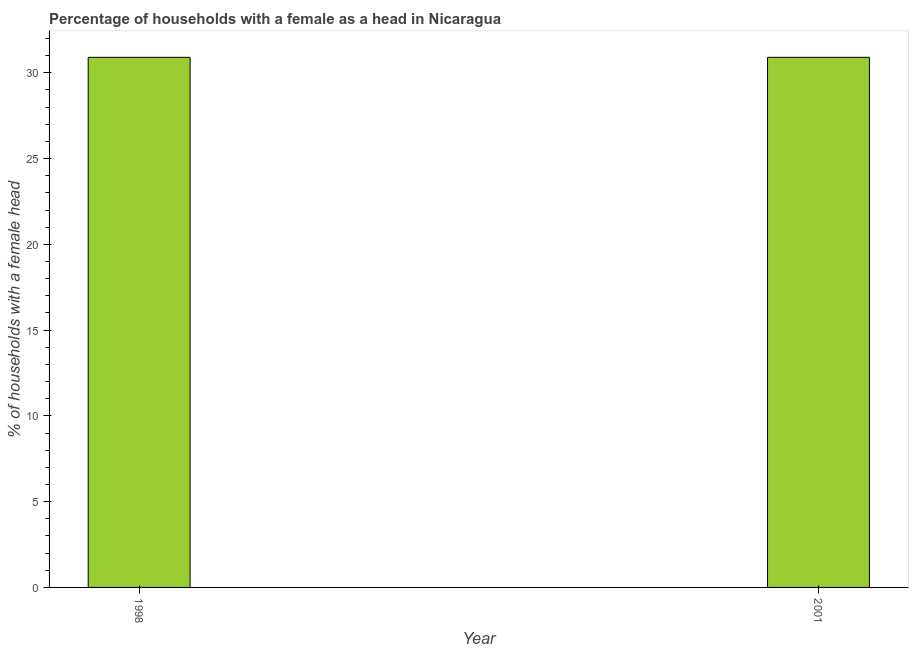Does the graph contain grids?
Keep it short and to the point. No. What is the title of the graph?
Ensure brevity in your answer.  Percentage of households with a female as a head in Nicaragua. What is the label or title of the X-axis?
Keep it short and to the point. Year. What is the label or title of the Y-axis?
Your response must be concise. % of households with a female head. What is the number of female supervised households in 2001?
Give a very brief answer. 30.9. Across all years, what is the maximum number of female supervised households?
Offer a terse response. 30.9. Across all years, what is the minimum number of female supervised households?
Make the answer very short. 30.9. In which year was the number of female supervised households maximum?
Provide a short and direct response. 1998. In which year was the number of female supervised households minimum?
Keep it short and to the point. 1998. What is the sum of the number of female supervised households?
Offer a very short reply. 61.8. What is the average number of female supervised households per year?
Provide a succinct answer. 30.9. What is the median number of female supervised households?
Offer a very short reply. 30.9. In how many years, is the number of female supervised households greater than 17 %?
Provide a succinct answer. 2. Is the number of female supervised households in 1998 less than that in 2001?
Offer a terse response. No. How many bars are there?
Offer a terse response. 2. How many years are there in the graph?
Offer a very short reply. 2. What is the difference between two consecutive major ticks on the Y-axis?
Give a very brief answer. 5. Are the values on the major ticks of Y-axis written in scientific E-notation?
Your response must be concise. No. What is the % of households with a female head in 1998?
Make the answer very short. 30.9. What is the % of households with a female head of 2001?
Your response must be concise. 30.9. What is the difference between the % of households with a female head in 1998 and 2001?
Provide a succinct answer. 0. What is the ratio of the % of households with a female head in 1998 to that in 2001?
Provide a succinct answer. 1. 